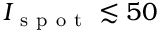<formula> <loc_0><loc_0><loc_500><loc_500>I _ { s p o t } \lesssim 5 0</formula> 